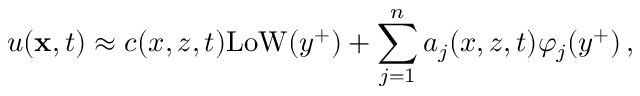Convert formula to latex. <formula><loc_0><loc_0><loc_500><loc_500>u ( { x } , t ) \approx c ( x , z , t ) L o W ( y ^ { + } ) + \sum _ { j = 1 } ^ { n } a _ { j } ( x , z , t ) \varphi _ { j } ( y ^ { + } ) \, ,</formula> 